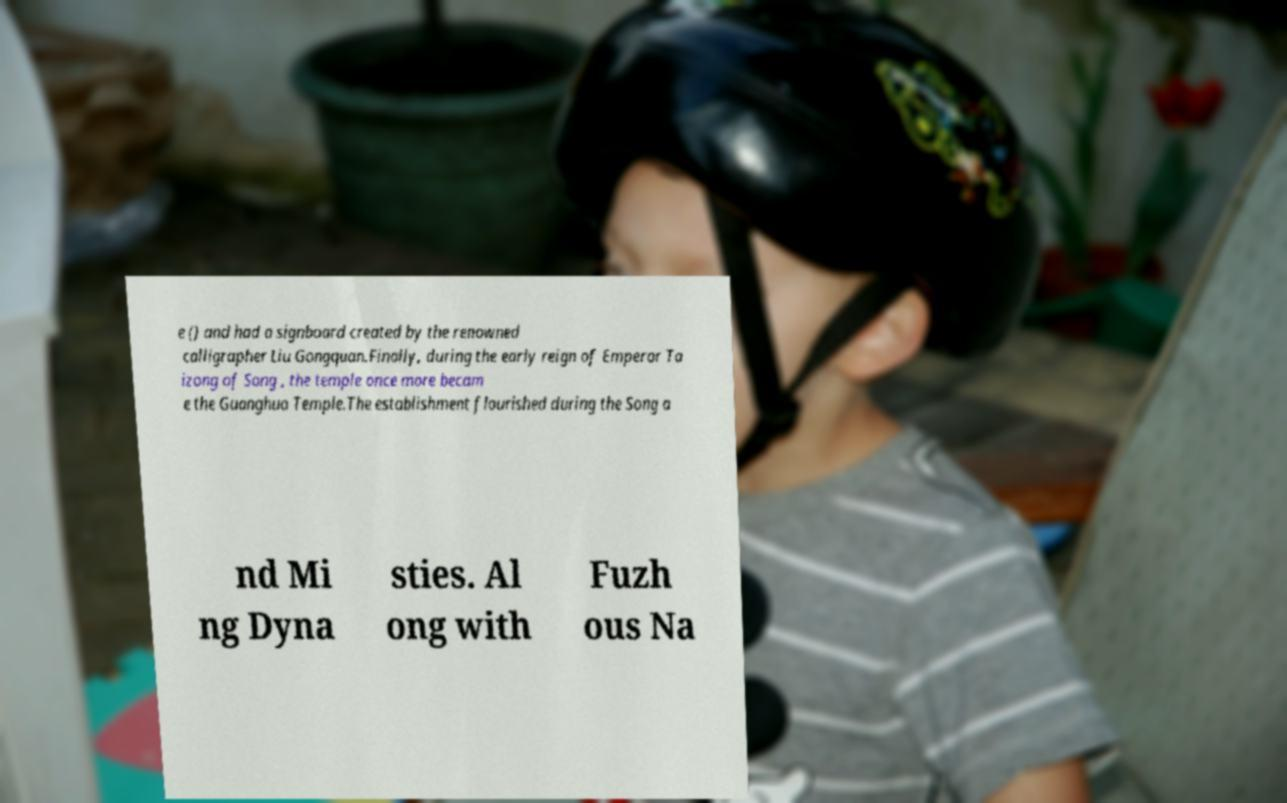Could you assist in decoding the text presented in this image and type it out clearly? e () and had a signboard created by the renowned calligrapher Liu Gongquan.Finally, during the early reign of Emperor Ta izong of Song , the temple once more becam e the Guanghua Temple.The establishment flourished during the Song a nd Mi ng Dyna sties. Al ong with Fuzh ous Na 